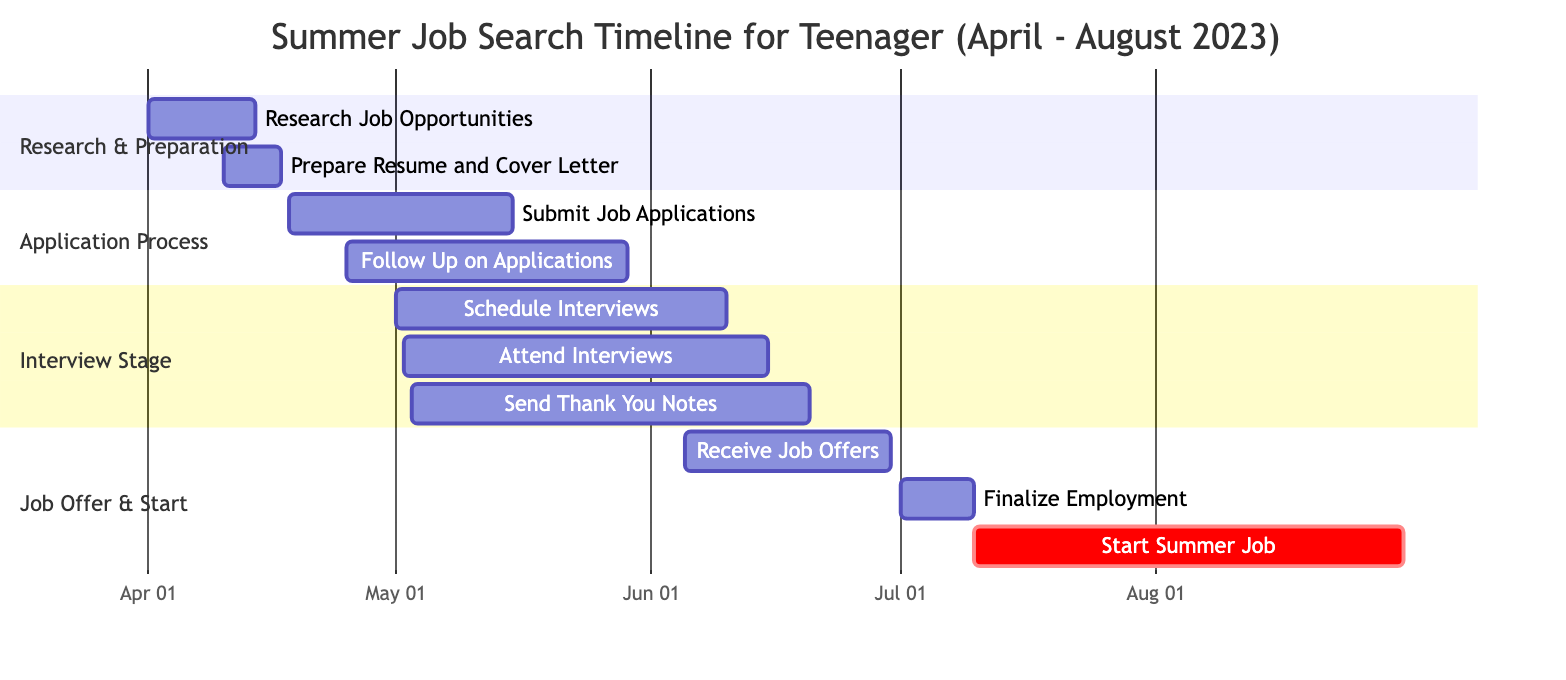What is the task that starts on April 1, 2023? The diagram indicates that "Research Job Opportunities" is the task that begins on April 1, 2023, as shown in the timeline section.
Answer: Research Job Opportunities How long does the "Prepare Resume and Cover Letter" task last? By checking the start and end dates for this task, we see it starts on April 10, 2023, and ends on April 17, 2023. Thus, it lasts for 7 days.
Answer: 7 days Which task overlaps with "Submit Job Applications" and begins earlier? Looking closely, "Follow Up on Applications" begins on April 25, 2023, which overlaps with "Submit Job Applications" that runs until May 15, 2023.
Answer: Follow Up on Applications What is the critical task in the timeline? The diagram marks "Start Summer Job" as a critical task, meaning it is crucial to the project timeline and is emphasized as such in the section "Job Offer & Start".
Answer: Start Summer Job On what date should "Thank You Notes" be sent by? Referring to the task "Send Thank You Notes", it starts on May 3, 2023, and ends on June 20, 2023. The last action in this task should be taken by June 20, 2023.
Answer: June 20, 2023 How many tasks are in the "Interview Stage" section? There are three tasks in the "Interview Stage" section: "Schedule Interviews", "Attend Interviews", and "Send Thank You Notes". Hence, the total number is three.
Answer: 3 When is the latest date to receive job offers? The task "Receive Job Offers" ends on June 30, 2023, which is the latest date listed for receiving job offers according to the timeline.
Answer: June 30, 2023 What task follows "Finalize Employment"? After looking at the tasks listed, "Start Summer Job" follows "Finalize Employment" in the Gantt chart sequence, and thus is the next task.
Answer: Start Summer Job 